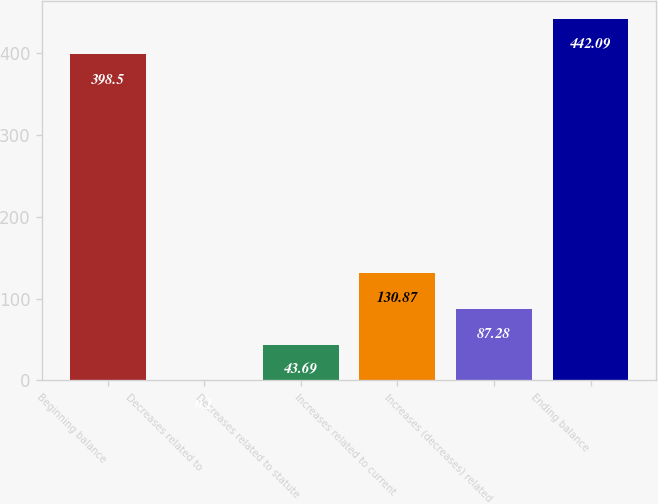Convert chart. <chart><loc_0><loc_0><loc_500><loc_500><bar_chart><fcel>Beginning balance<fcel>Decreases related to<fcel>Decreases related to statute<fcel>Increases related to current<fcel>Increases (decreases) related<fcel>Ending balance<nl><fcel>398.5<fcel>0.1<fcel>43.69<fcel>130.87<fcel>87.28<fcel>442.09<nl></chart> 